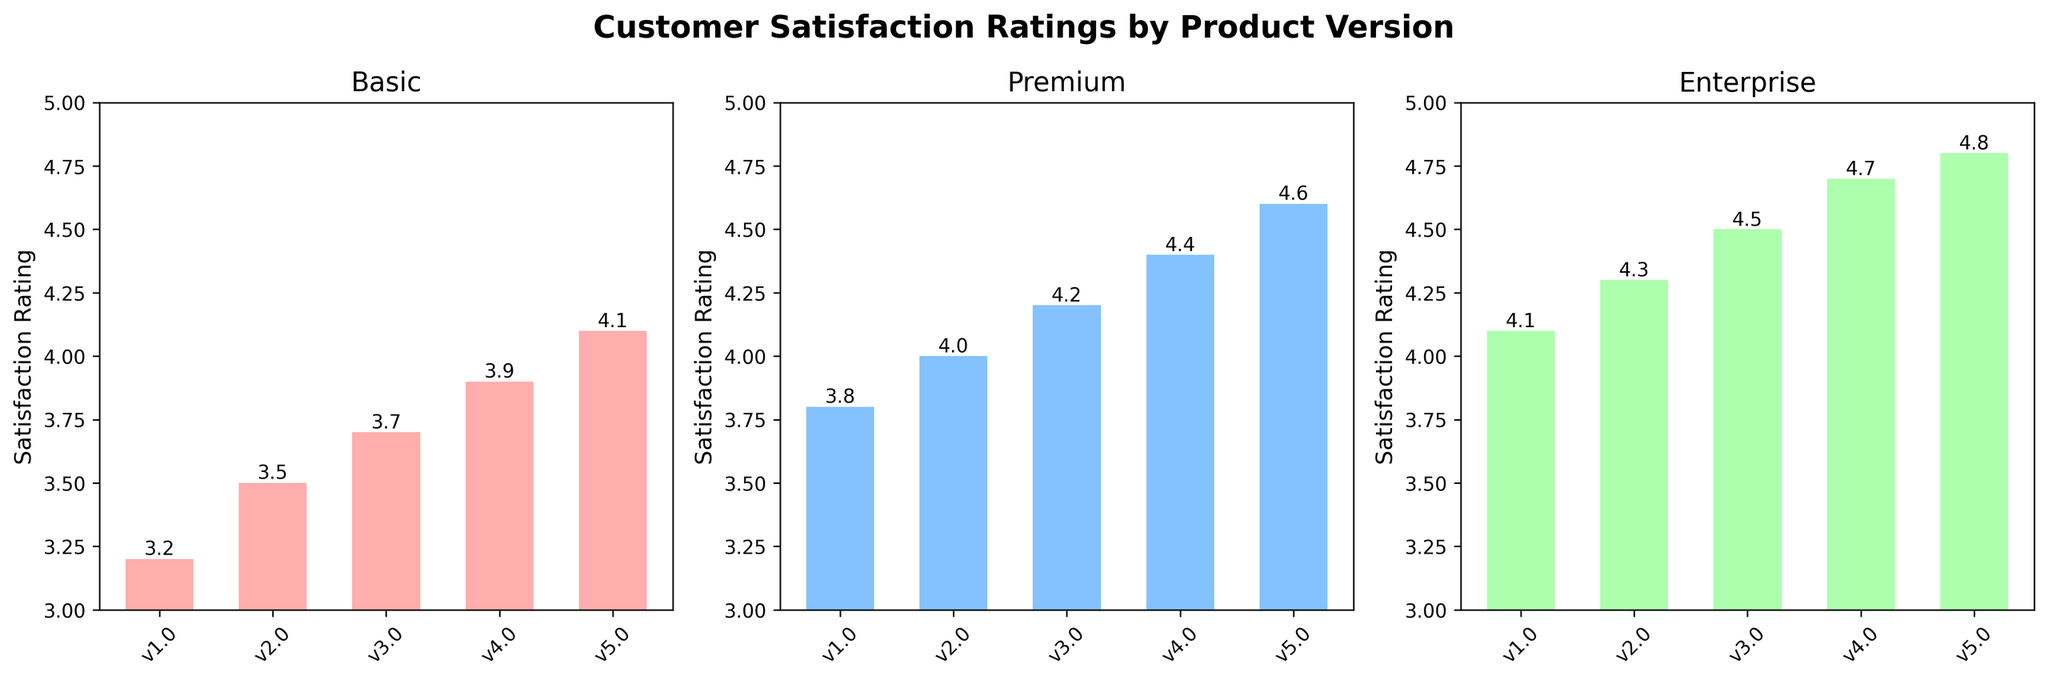What's the title of the figure? The title is prominently displayed at the top center of the figure. The title reads 'Customer Satisfaction Ratings by Product Version'.
Answer: Customer Satisfaction Ratings by Product Version What is the satisfaction rating of the Premium plan in version v3.0? The satisfaction rating for the Premium plan is shown by the height of the bar labeled 'v3.0' in the second subplot, which is titled 'Premium'. The value at the top of the bar is 4.2.
Answer: 4.2 Which product version shows the highest satisfaction rating in the Basic plan? To find the highest satisfaction rating in the Basic plan, look at the bars in the first subplot titled 'Basic'. The version with the highest bar and value is 'v5.0' with a rating of 4.1.
Answer: v5.0 What is the difference in satisfaction ratings between the Basic and Enterprise plans for version v1.0? Check the heights of the bars for version 'v1.0' in both the 'Basic' and 'Enterprise' subplots. The Basic plan has a rating of 3.2 and the Enterprise plan has a rating of 4.1. The difference is 4.1 - 3.2 = 0.9.
Answer: 0.9 What are the y-axis limits for all subplots? The y-axis limits are observed from the y-tick values on all three subplots. They all range from 3 to 5.
Answer: 3 to 5 What's the overall trend in satisfaction ratings for the Enterprise plan from v1.0 to v5.0? Looking at the 'Enterprise' subplot, the heights of the bars increase steadily from v1.0 to v5.0. The ratings go from 4.1 to 4.8, indicating a consistent upward trend.
Answer: Upward trend By how much did the satisfaction rating change for the Basic plan from version v2.0 to v4.0? The Basic plan ratings for these versions can be found at the top of the bars in the first subplot. v2.0 has a rating of 3.5 and v4.0 has a rating of 3.9. The change is 3.9 - 3.5 = 0.4.
Answer: 0.4 Is the Premium plan's satisfaction rating always higher than the Basic plan's across all versions? Compare the heights of the bars in the 'Premium' subplot to those in the 'Basic' subplot for each version v1.0 to v5.0. In all cases, the bars for the Premium plan are higher than those for the Basic plan.
Answer: Yes What is the average satisfaction rating for all product versions in the Enterprise plan? Add the ratings for the Enterprise plan across all versions: (4.1 + 4.3 + 4.5 + 4.7 + 4.8) = 22.4 and divide by the number of versions, which is 5. This gives 22.4 / 5 = 4.48.
Answer: 4.48 